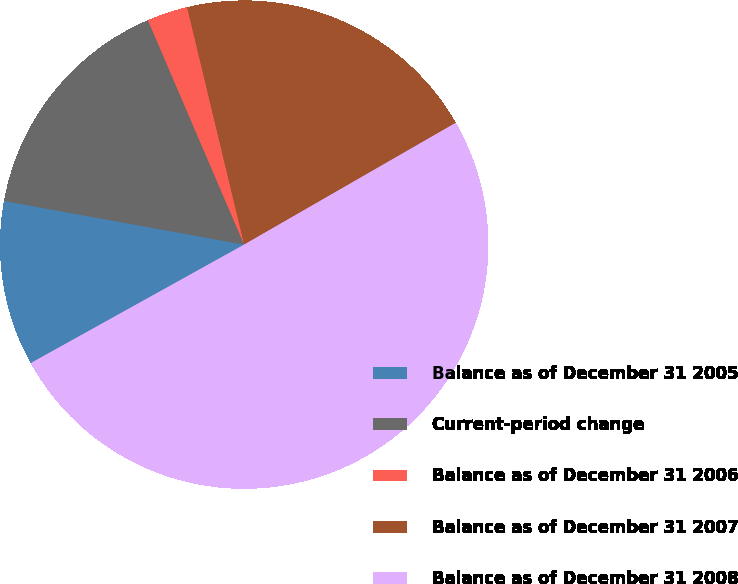<chart> <loc_0><loc_0><loc_500><loc_500><pie_chart><fcel>Balance as of December 31 2005<fcel>Current-period change<fcel>Balance as of December 31 2006<fcel>Balance as of December 31 2007<fcel>Balance as of December 31 2008<nl><fcel>10.93%<fcel>15.69%<fcel>2.69%<fcel>20.44%<fcel>50.24%<nl></chart> 